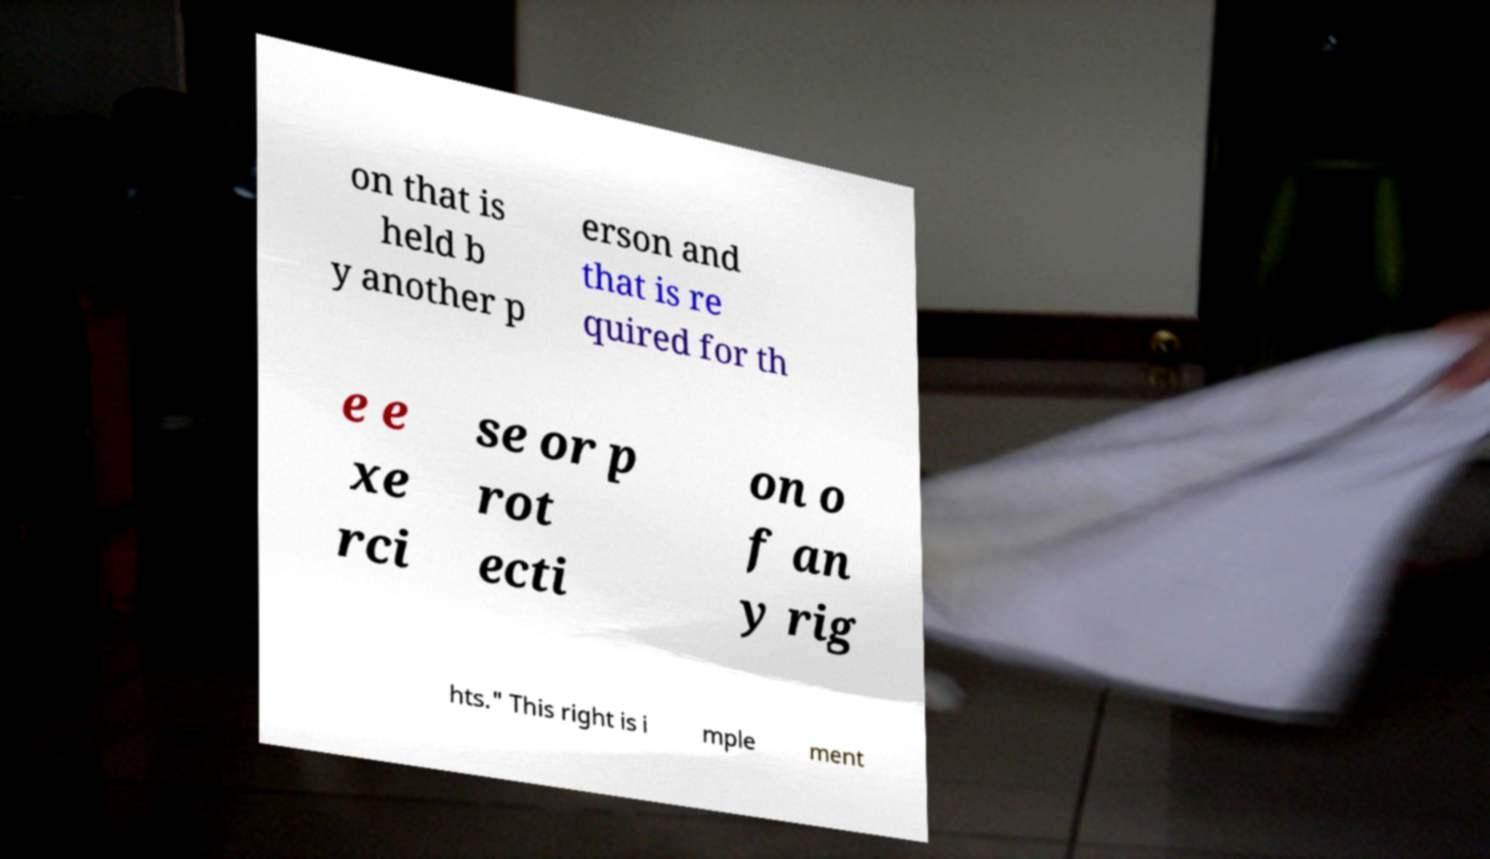Can you read and provide the text displayed in the image?This photo seems to have some interesting text. Can you extract and type it out for me? on that is held b y another p erson and that is re quired for th e e xe rci se or p rot ecti on o f an y rig hts." This right is i mple ment 